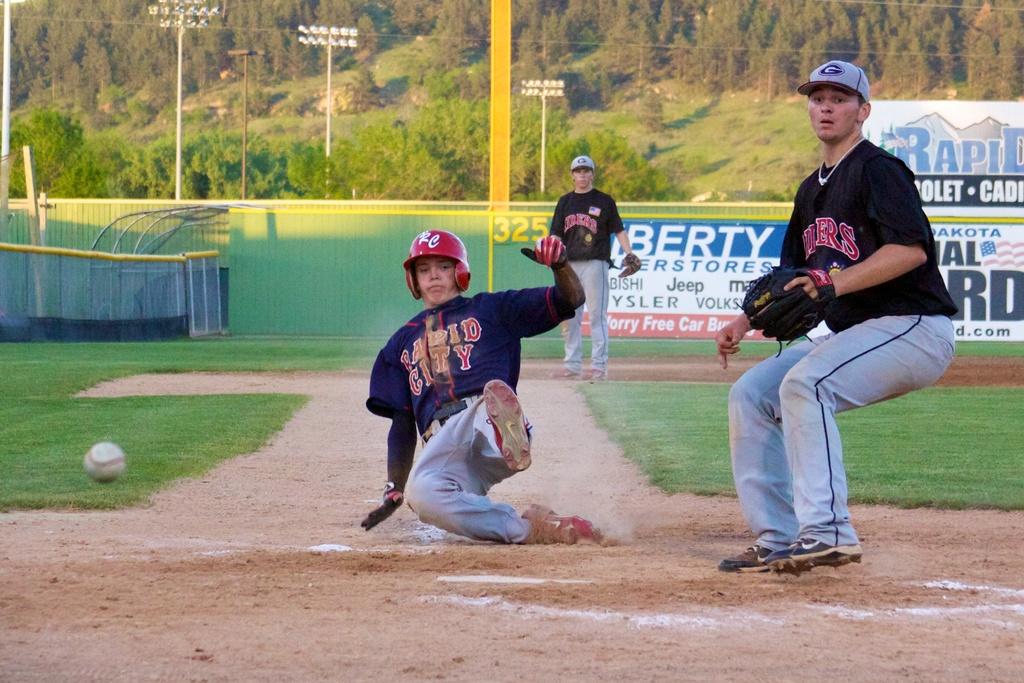What city is on the sliding player's jersey?
Provide a succinct answer. Rapid city. What advertisement is shown in the back?
Your answer should be very brief. Liberty. 